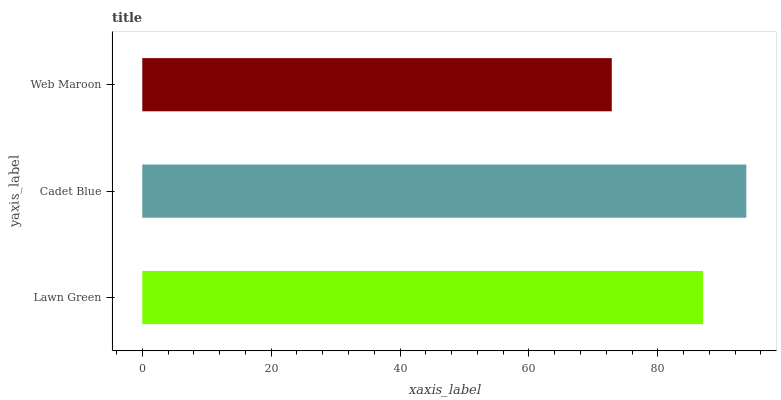Is Web Maroon the minimum?
Answer yes or no. Yes. Is Cadet Blue the maximum?
Answer yes or no. Yes. Is Cadet Blue the minimum?
Answer yes or no. No. Is Web Maroon the maximum?
Answer yes or no. No. Is Cadet Blue greater than Web Maroon?
Answer yes or no. Yes. Is Web Maroon less than Cadet Blue?
Answer yes or no. Yes. Is Web Maroon greater than Cadet Blue?
Answer yes or no. No. Is Cadet Blue less than Web Maroon?
Answer yes or no. No. Is Lawn Green the high median?
Answer yes or no. Yes. Is Lawn Green the low median?
Answer yes or no. Yes. Is Web Maroon the high median?
Answer yes or no. No. Is Cadet Blue the low median?
Answer yes or no. No. 